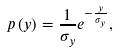<formula> <loc_0><loc_0><loc_500><loc_500>p \left ( y \right ) = \frac { 1 } { \sigma _ { y } } e ^ { - \frac { y } { \sigma _ { y } } } ,</formula> 